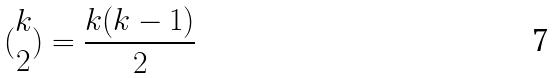<formula> <loc_0><loc_0><loc_500><loc_500>( \begin{matrix} k \\ 2 \end{matrix} ) = \frac { k ( k - 1 ) } { 2 }</formula> 